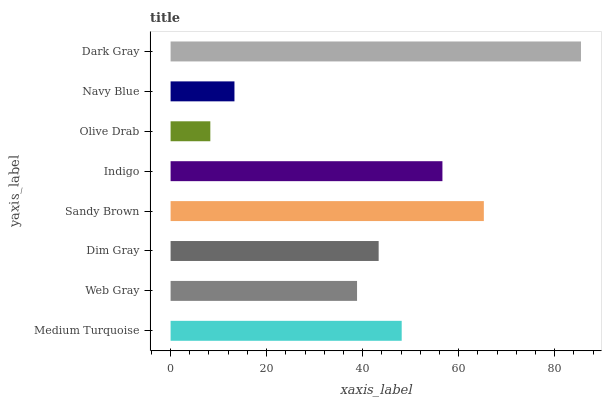Is Olive Drab the minimum?
Answer yes or no. Yes. Is Dark Gray the maximum?
Answer yes or no. Yes. Is Web Gray the minimum?
Answer yes or no. No. Is Web Gray the maximum?
Answer yes or no. No. Is Medium Turquoise greater than Web Gray?
Answer yes or no. Yes. Is Web Gray less than Medium Turquoise?
Answer yes or no. Yes. Is Web Gray greater than Medium Turquoise?
Answer yes or no. No. Is Medium Turquoise less than Web Gray?
Answer yes or no. No. Is Medium Turquoise the high median?
Answer yes or no. Yes. Is Dim Gray the low median?
Answer yes or no. Yes. Is Indigo the high median?
Answer yes or no. No. Is Indigo the low median?
Answer yes or no. No. 